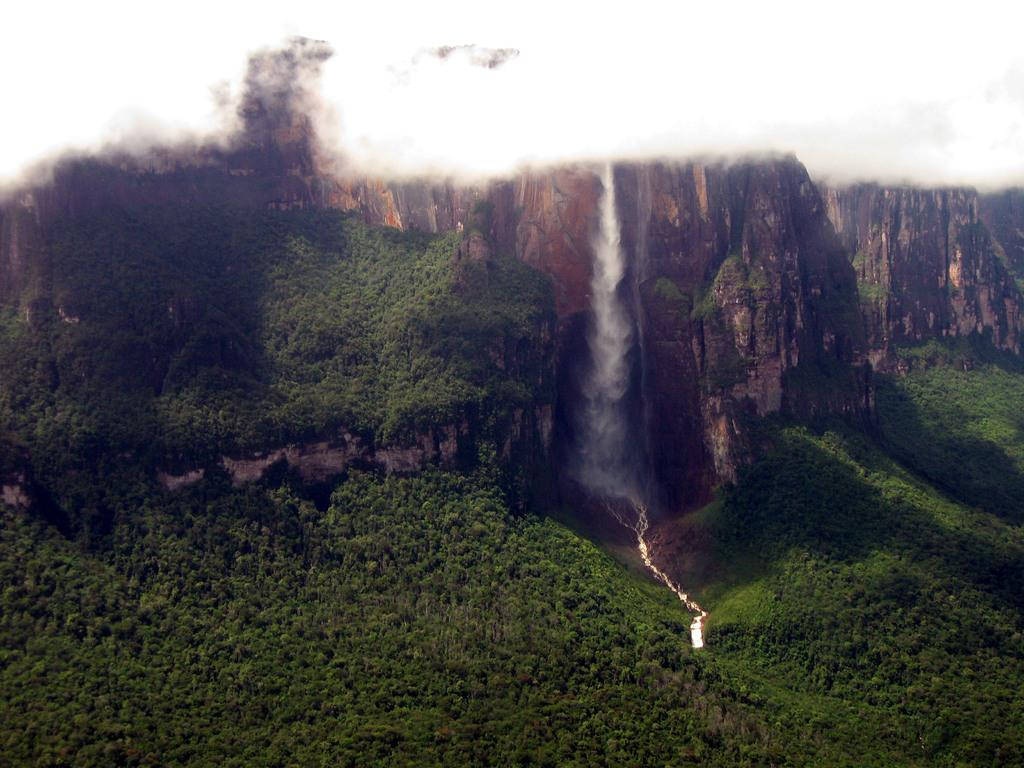What type of vegetation is present in the image? There are trees in the image. What can be seen in the distance in the image? There are hills in the background of the image. What is the color of the hills? The hills are brown in color. What is the unusual feature on the left side of the image? There is black smoke on the left side of the image. Can you see a group of yaks grazing on the hills in the image? There are no yaks present in the image; it only features trees, hills, and black smoke. 